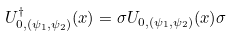Convert formula to latex. <formula><loc_0><loc_0><loc_500><loc_500>U _ { 0 , ( \psi _ { 1 } , \psi _ { 2 } ) } ^ { \dagger } ( x ) = \sigma U _ { 0 , ( \psi _ { 1 } , \psi _ { 2 } ) } ( x ) \sigma</formula> 